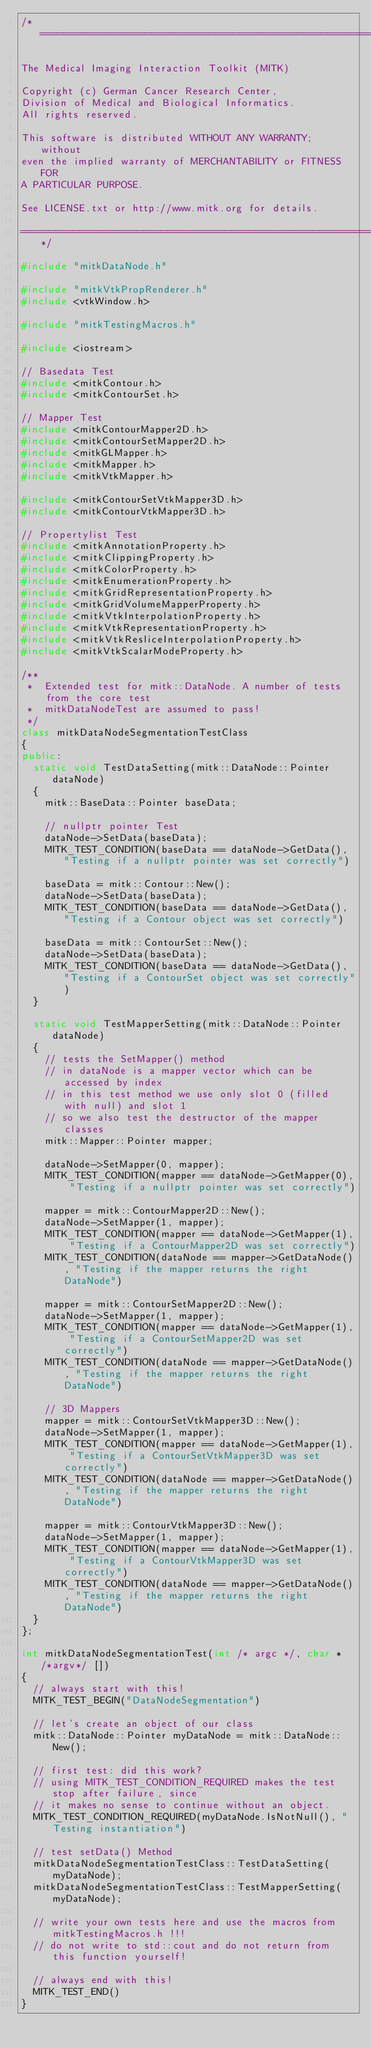<code> <loc_0><loc_0><loc_500><loc_500><_C++_>/*===================================================================

The Medical Imaging Interaction Toolkit (MITK)

Copyright (c) German Cancer Research Center,
Division of Medical and Biological Informatics.
All rights reserved.

This software is distributed WITHOUT ANY WARRANTY; without
even the implied warranty of MERCHANTABILITY or FITNESS FOR
A PARTICULAR PURPOSE.

See LICENSE.txt or http://www.mitk.org for details.

===================================================================*/

#include "mitkDataNode.h"

#include "mitkVtkPropRenderer.h"
#include <vtkWindow.h>

#include "mitkTestingMacros.h"

#include <iostream>

// Basedata Test
#include <mitkContour.h>
#include <mitkContourSet.h>

// Mapper Test
#include <mitkContourMapper2D.h>
#include <mitkContourSetMapper2D.h>
#include <mitkGLMapper.h>
#include <mitkMapper.h>
#include <mitkVtkMapper.h>

#include <mitkContourSetVtkMapper3D.h>
#include <mitkContourVtkMapper3D.h>

// Propertylist Test
#include <mitkAnnotationProperty.h>
#include <mitkClippingProperty.h>
#include <mitkColorProperty.h>
#include <mitkEnumerationProperty.h>
#include <mitkGridRepresentationProperty.h>
#include <mitkGridVolumeMapperProperty.h>
#include <mitkVtkInterpolationProperty.h>
#include <mitkVtkRepresentationProperty.h>
#include <mitkVtkResliceInterpolationProperty.h>
#include <mitkVtkScalarModeProperty.h>

/**
 *  Extended test for mitk::DataNode. A number of tests from the core test
 *  mitkDataNodeTest are assumed to pass!
 */
class mitkDataNodeSegmentationTestClass
{
public:
  static void TestDataSetting(mitk::DataNode::Pointer dataNode)
  {
    mitk::BaseData::Pointer baseData;

    // nullptr pointer Test
    dataNode->SetData(baseData);
    MITK_TEST_CONDITION(baseData == dataNode->GetData(), "Testing if a nullptr pointer was set correctly")

    baseData = mitk::Contour::New();
    dataNode->SetData(baseData);
    MITK_TEST_CONDITION(baseData == dataNode->GetData(), "Testing if a Contour object was set correctly")

    baseData = mitk::ContourSet::New();
    dataNode->SetData(baseData);
    MITK_TEST_CONDITION(baseData == dataNode->GetData(), "Testing if a ContourSet object was set correctly")
  }

  static void TestMapperSetting(mitk::DataNode::Pointer dataNode)
  {
    // tests the SetMapper() method
    // in dataNode is a mapper vector which can be accessed by index
    // in this test method we use only slot 0 (filled with null) and slot 1
    // so we also test the destructor of the mapper classes
    mitk::Mapper::Pointer mapper;

    dataNode->SetMapper(0, mapper);
    MITK_TEST_CONDITION(mapper == dataNode->GetMapper(0), "Testing if a nullptr pointer was set correctly")

    mapper = mitk::ContourMapper2D::New();
    dataNode->SetMapper(1, mapper);
    MITK_TEST_CONDITION(mapper == dataNode->GetMapper(1), "Testing if a ContourMapper2D was set correctly")
    MITK_TEST_CONDITION(dataNode == mapper->GetDataNode(), "Testing if the mapper returns the right DataNode")

    mapper = mitk::ContourSetMapper2D::New();
    dataNode->SetMapper(1, mapper);
    MITK_TEST_CONDITION(mapper == dataNode->GetMapper(1), "Testing if a ContourSetMapper2D was set correctly")
    MITK_TEST_CONDITION(dataNode == mapper->GetDataNode(), "Testing if the mapper returns the right DataNode")

    // 3D Mappers
    mapper = mitk::ContourSetVtkMapper3D::New();
    dataNode->SetMapper(1, mapper);
    MITK_TEST_CONDITION(mapper == dataNode->GetMapper(1), "Testing if a ContourSetVtkMapper3D was set correctly")
    MITK_TEST_CONDITION(dataNode == mapper->GetDataNode(), "Testing if the mapper returns the right DataNode")

    mapper = mitk::ContourVtkMapper3D::New();
    dataNode->SetMapper(1, mapper);
    MITK_TEST_CONDITION(mapper == dataNode->GetMapper(1), "Testing if a ContourVtkMapper3D was set correctly")
    MITK_TEST_CONDITION(dataNode == mapper->GetDataNode(), "Testing if the mapper returns the right DataNode")
  }
};

int mitkDataNodeSegmentationTest(int /* argc */, char * /*argv*/ [])
{
  // always start with this!
  MITK_TEST_BEGIN("DataNodeSegmentation")

  // let's create an object of our class
  mitk::DataNode::Pointer myDataNode = mitk::DataNode::New();

  // first test: did this work?
  // using MITK_TEST_CONDITION_REQUIRED makes the test stop after failure, since
  // it makes no sense to continue without an object.
  MITK_TEST_CONDITION_REQUIRED(myDataNode.IsNotNull(), "Testing instantiation")

  // test setData() Method
  mitkDataNodeSegmentationTestClass::TestDataSetting(myDataNode);
  mitkDataNodeSegmentationTestClass::TestMapperSetting(myDataNode);

  // write your own tests here and use the macros from mitkTestingMacros.h !!!
  // do not write to std::cout and do not return from this function yourself!

  // always end with this!
  MITK_TEST_END()
}
</code> 